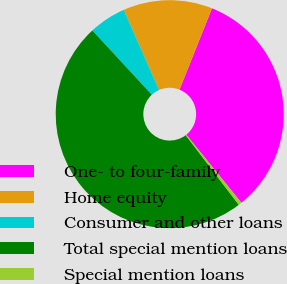<chart> <loc_0><loc_0><loc_500><loc_500><pie_chart><fcel>One- to four-family<fcel>Home equity<fcel>Consumer and other loans<fcel>Total special mention loans<fcel>Special mention loans<nl><fcel>33.13%<fcel>12.65%<fcel>5.26%<fcel>48.49%<fcel>0.46%<nl></chart> 